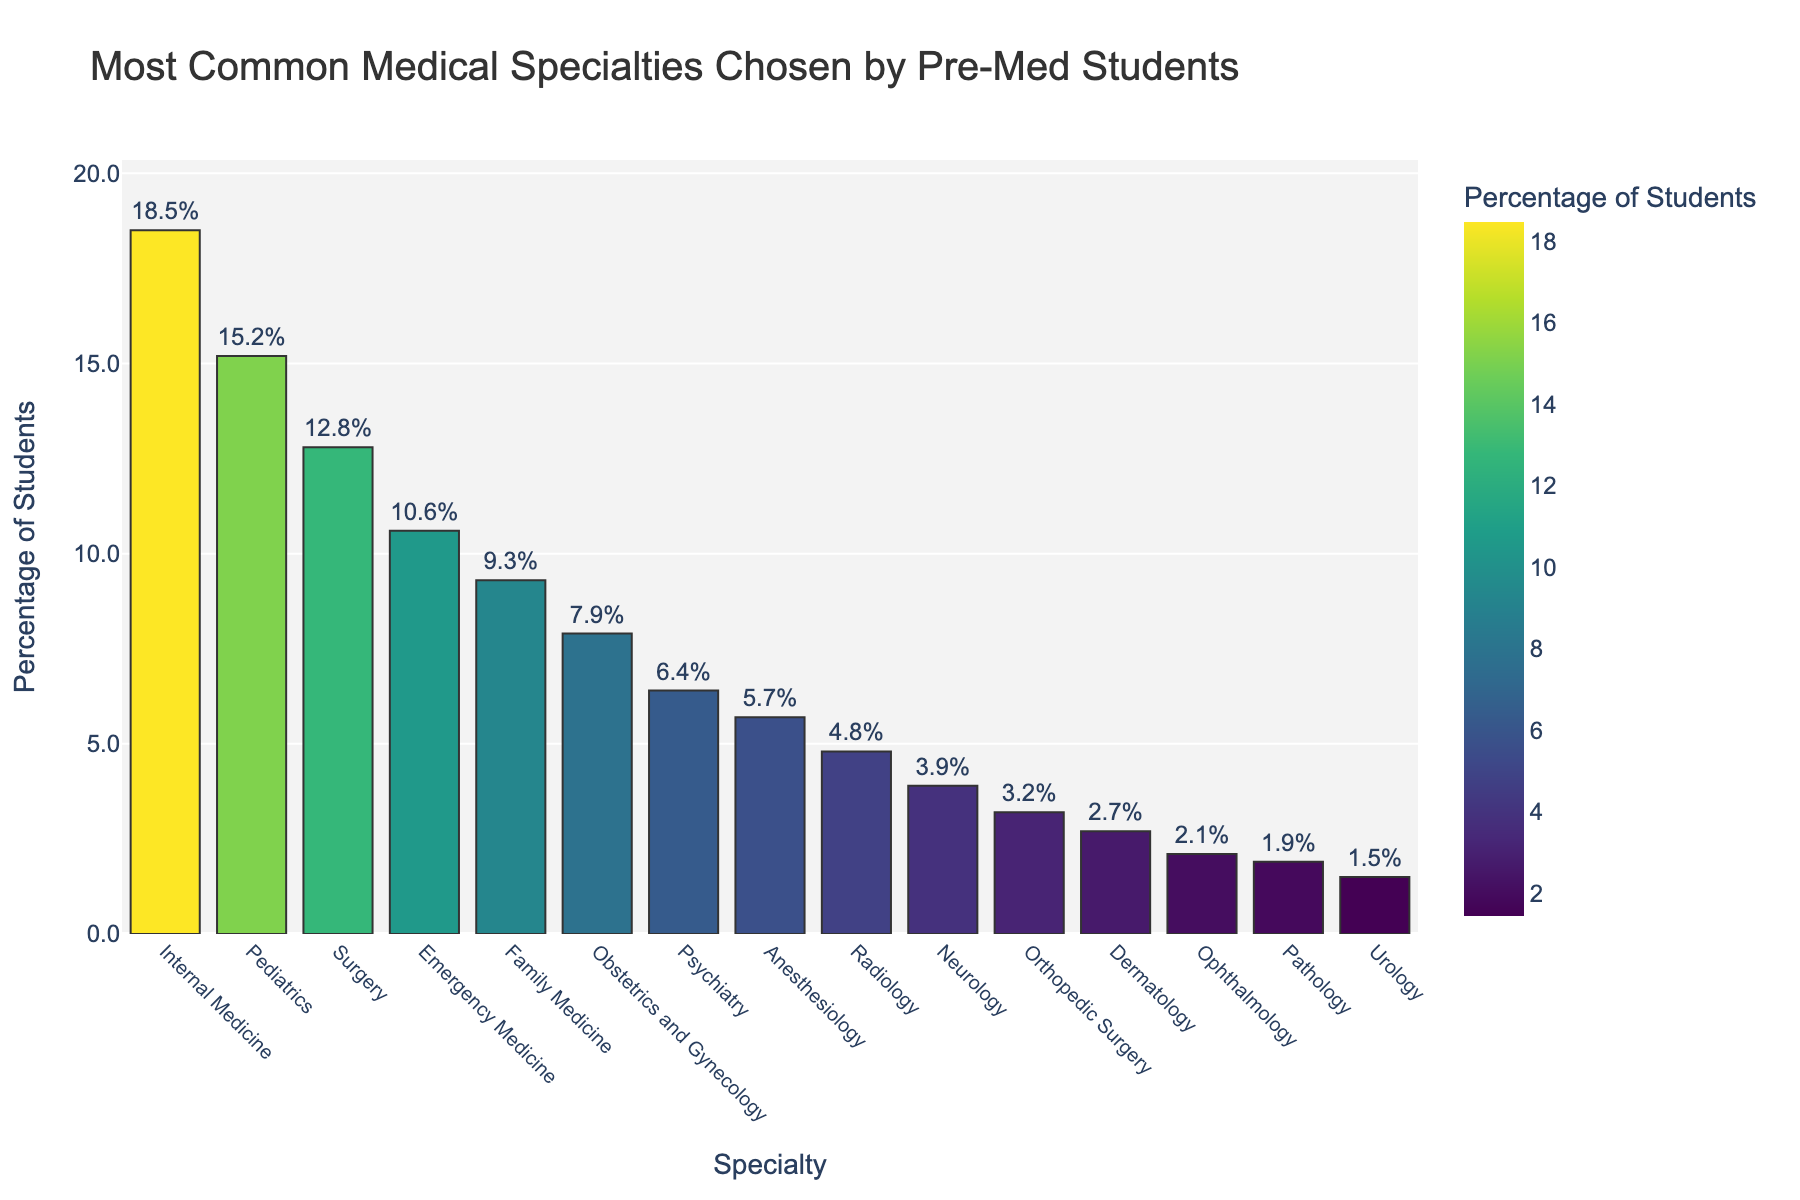What's the most common medical specialty chosen by pre-med students? The bar chart shows that Internal Medicine has the highest bar, indicating it is the most popular specialty.
Answer: Internal Medicine Which specialty has the lowest percentage of pre-med students choosing it? The bar chart shows that Urology has the shortest bar, indicating it has the lowest percentage.
Answer: Urology What is the total percentage of students choosing the top three specialties combined? The top three specialties are Internal Medicine (18.5%), Pediatrics (15.2%), and Surgery (12.8%). Adding these together gives 18.5 + 15.2 + 12.8 = 46.5%.
Answer: 46.5% Which specialty has a higher percentage, Psychiatry or Anesthesiology? Observing the bar heights for both specialties, Psychiatry has 6.4% and Anesthesiology has 5.7%. Psychiatry's bar is higher.
Answer: Psychiatry By how much does the percentage of students choosing Surgery exceed those choosing Dermatology? The percentage for Surgery is 12.8% and for Dermatology is 2.7%. Subtracting these, 12.8 - 2.7 = 10.1%.
Answer: 10.1% Approximately how many more percentage points does Internal Medicine have compared to Radiology? Internal Medicine has 18.5% and Radiology has 4.8%. Subtracting these gives 18.5 - 4.8 = 13.7%.
Answer: 13.7% What is the average percentage of students choosing Pediatrics, Obstetrics and Gynecology, and Emergency Medicine? The percentages are Pediatrics (15.2%), Obstetrics and Gynecology (7.9%), and Emergency Medicine (10.6%). Adding these and dividing by 3 gives (15.2 + 7.9 + 10.6)/3 = 33.7/3 = 11.23%.
Answer: 11.23% Which two specialties combined have a total percentage closest to 15%? Family Medicine (9.3%) and Anesthesiology (5.7%) together have 9.3 + 5.7 = 15%.
Answer: Family Medicine and Anesthesiology What is the difference in percentage between Ophthalmology and Neurology? Ophthalmology is at 2.1% and Neurology is at 3.9%. Subtracting these gives 3.9 - 2.1 = 1.8%.
Answer: 1.8% Which specialty has a percentage close to the median value of all the listed specialties? Listing all percentages in ascending order gives: 1.5, 1.9, 2.1, 2.7, 3.2, 3.9, 4.8, 5.7, 6.4, 7.9, 9.3, 10.6, 12.8, 15.2, 18.5. The median value is the 8th value, which is 5.7%. This corresponds to Anesthesiology.
Answer: Anesthesiology 